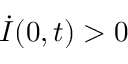<formula> <loc_0><loc_0><loc_500><loc_500>\dot { I } ( 0 , t ) > 0</formula> 